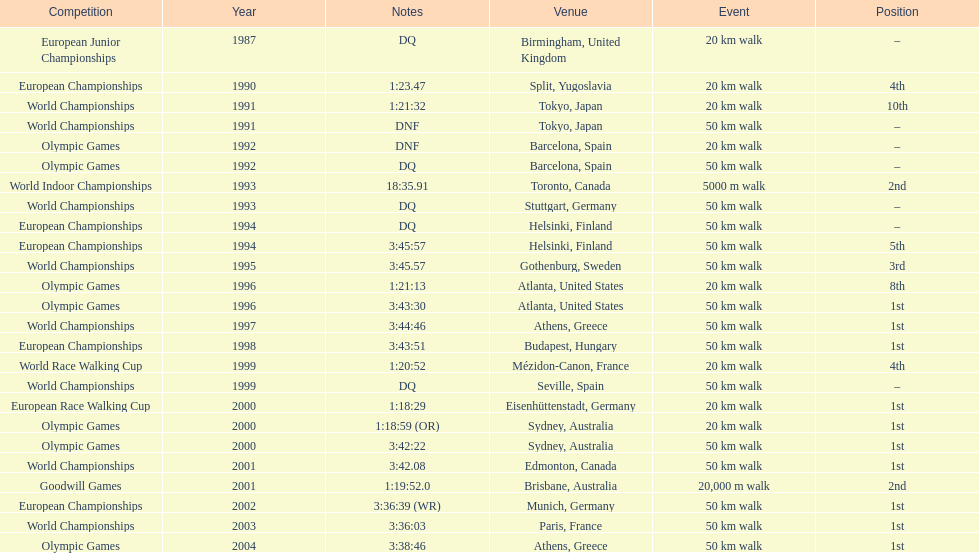How many times was korzeniowski disqualified from a competition? 5. 